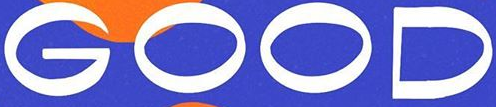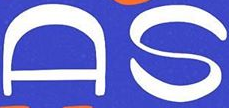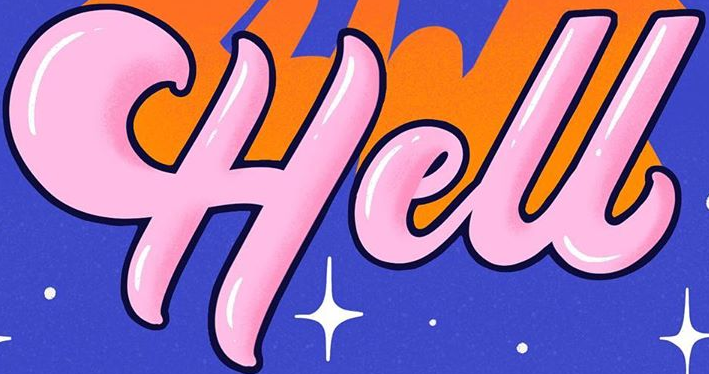What words can you see in these images in sequence, separated by a semicolon? GOOD; AS; Hell 